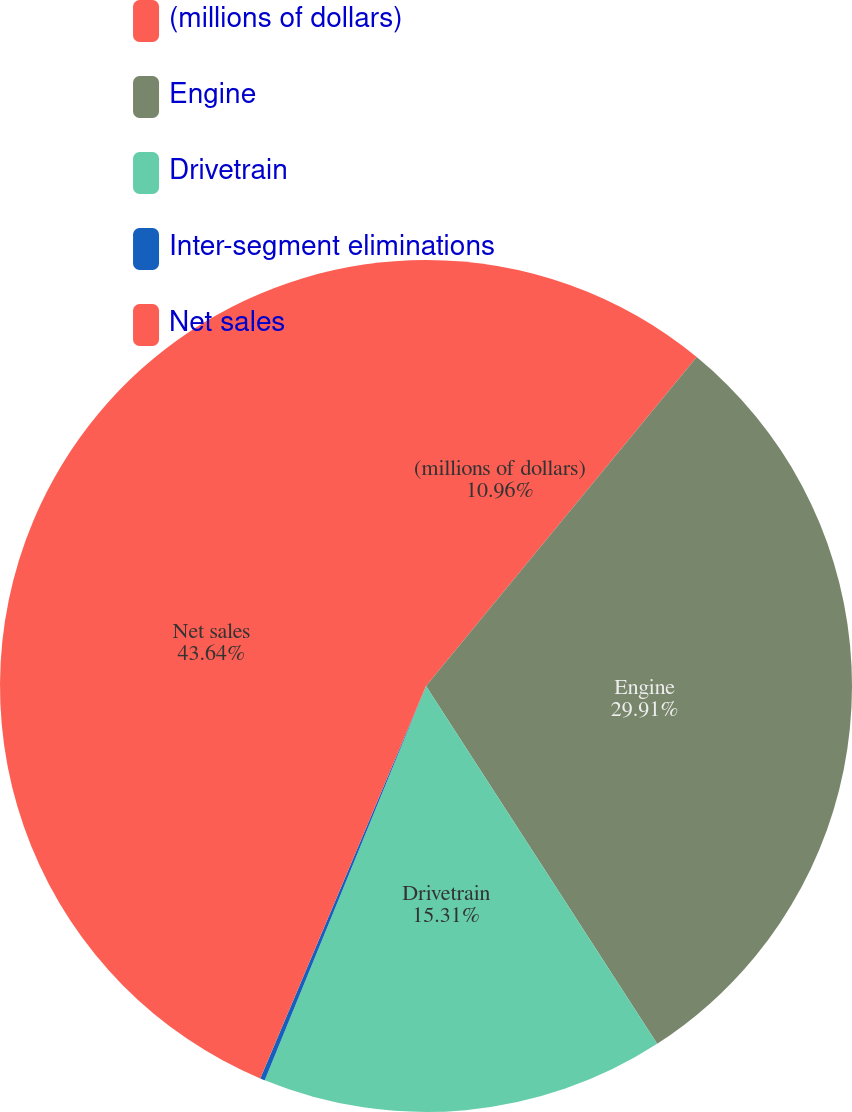Convert chart to OTSL. <chart><loc_0><loc_0><loc_500><loc_500><pie_chart><fcel>(millions of dollars)<fcel>Engine<fcel>Drivetrain<fcel>Inter-segment eliminations<fcel>Net sales<nl><fcel>10.96%<fcel>29.91%<fcel>15.31%<fcel>0.18%<fcel>43.64%<nl></chart> 